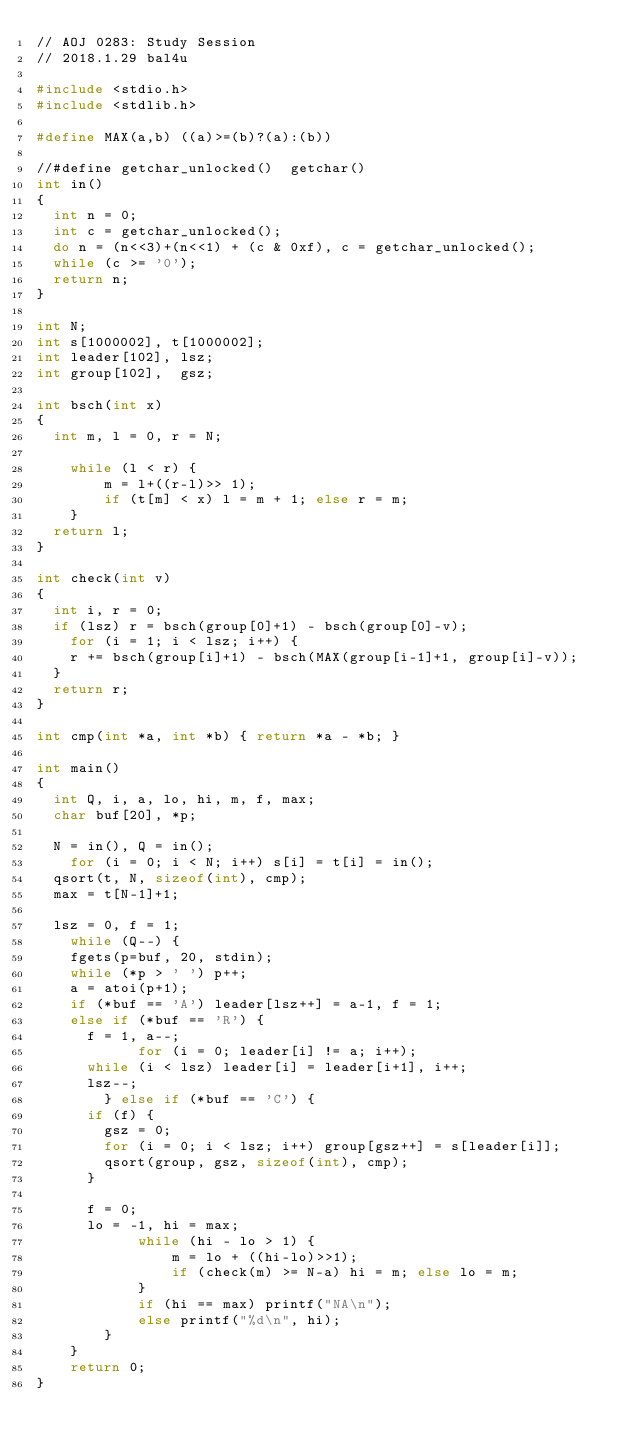<code> <loc_0><loc_0><loc_500><loc_500><_C_>// AOJ 0283: Study Session
// 2018.1.29 bal4u

#include <stdio.h>
#include <stdlib.h>

#define MAX(a,b) ((a)>=(b)?(a):(b))

//#define getchar_unlocked()  getchar()
int in()
{
	int n = 0;
	int c = getchar_unlocked();
	do n = (n<<3)+(n<<1) + (c & 0xf), c = getchar_unlocked();
	while (c >= '0');
	return n;
}

int N;
int s[1000002], t[1000002];
int leader[102], lsz;
int group[102],  gsz;

int bsch(int x)
{
	int m, l = 0, r = N;

    while (l < r) {
        m = l+((r-l)>> 1);
        if (t[m] < x) l = m + 1; else r = m;
    }
	return l;
}

int check(int v)
{
	int i, r = 0;
	if (lsz) r = bsch(group[0]+1) - bsch(group[0]-v);
    for (i = 1; i < lsz; i++) {
		r += bsch(group[i]+1) - bsch(MAX(group[i-1]+1, group[i]-v));
	}
	return r;
}

int cmp(int *a, int *b) { return *a - *b; }

int main()
{
	int Q, i, a, lo, hi, m, f, max;
	char buf[20], *p;
	
	N = in(), Q = in();
    for (i = 0; i < N; i++) s[i] = t[i] = in();
	qsort(t, N, sizeof(int), cmp);
	max = t[N-1]+1;

	lsz = 0, f = 1;
    while (Q--) {
		fgets(p=buf, 20, stdin);
		while (*p > ' ') p++;
		a = atoi(p+1);
		if (*buf == 'A') leader[lsz++] = a-1, f = 1;
		else if (*buf == 'R') {
			f = 1, a--;
            for (i = 0; leader[i] != a; i++);
			while (i < lsz) leader[i] = leader[i+1], i++;
			lsz--;
        } else if (*buf == 'C') {
			if (f) {
				gsz = 0;
				for (i = 0; i < lsz; i++) group[gsz++] = s[leader[i]];
				qsort(group, gsz, sizeof(int), cmp);
			}

			f = 0;
			lo = -1, hi = max;
            while (hi - lo > 1) {
                m = lo + ((hi-lo)>>1);
                if (check(m) >= N-a) hi = m; else lo = m;
            }
            if (hi == max) printf("NA\n");
            else printf("%d\n", hi);
        }
    }
    return 0;
}
</code> 